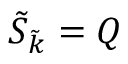<formula> <loc_0><loc_0><loc_500><loc_500>\tilde { S } _ { \tilde { k } } = Q</formula> 